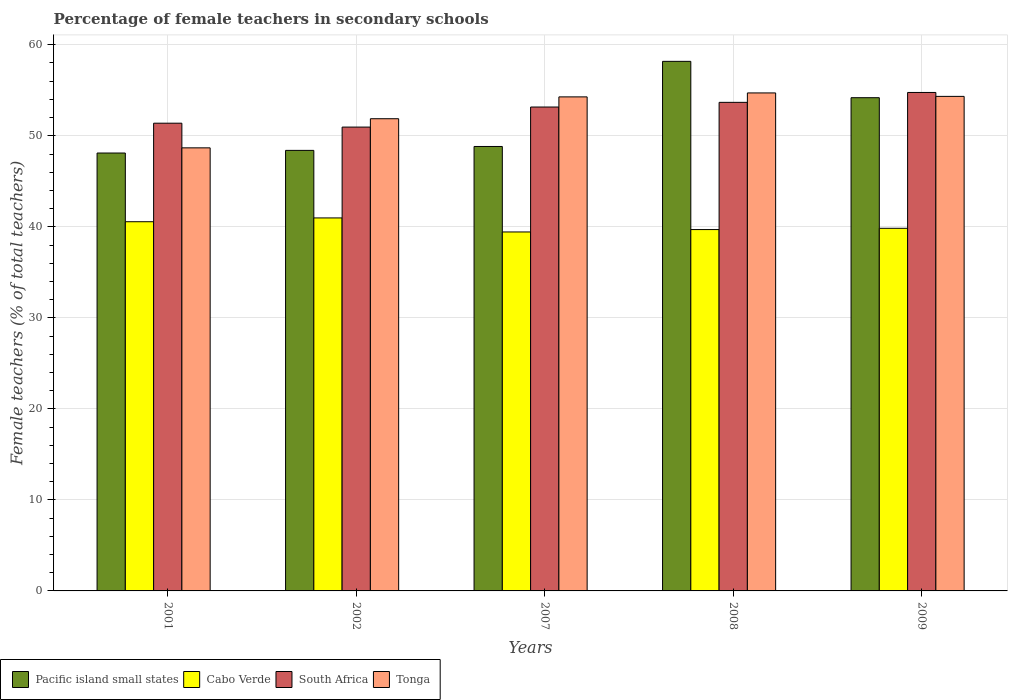How many different coloured bars are there?
Your answer should be very brief. 4. Are the number of bars on each tick of the X-axis equal?
Provide a short and direct response. Yes. How many bars are there on the 4th tick from the left?
Keep it short and to the point. 4. How many bars are there on the 1st tick from the right?
Your response must be concise. 4. In how many cases, is the number of bars for a given year not equal to the number of legend labels?
Make the answer very short. 0. What is the percentage of female teachers in South Africa in 2001?
Your answer should be very brief. 51.39. Across all years, what is the maximum percentage of female teachers in Tonga?
Make the answer very short. 54.71. Across all years, what is the minimum percentage of female teachers in Tonga?
Provide a short and direct response. 48.68. What is the total percentage of female teachers in South Africa in the graph?
Give a very brief answer. 263.95. What is the difference between the percentage of female teachers in Cabo Verde in 2001 and that in 2007?
Ensure brevity in your answer.  1.13. What is the difference between the percentage of female teachers in Pacific island small states in 2008 and the percentage of female teachers in Cabo Verde in 2001?
Provide a succinct answer. 17.62. What is the average percentage of female teachers in Tonga per year?
Make the answer very short. 52.78. In the year 2002, what is the difference between the percentage of female teachers in Tonga and percentage of female teachers in Cabo Verde?
Your answer should be compact. 10.9. What is the ratio of the percentage of female teachers in South Africa in 2001 to that in 2007?
Provide a short and direct response. 0.97. Is the difference between the percentage of female teachers in Tonga in 2001 and 2008 greater than the difference between the percentage of female teachers in Cabo Verde in 2001 and 2008?
Make the answer very short. No. What is the difference between the highest and the second highest percentage of female teachers in Cabo Verde?
Keep it short and to the point. 0.42. What is the difference between the highest and the lowest percentage of female teachers in South Africa?
Your answer should be compact. 3.8. In how many years, is the percentage of female teachers in Tonga greater than the average percentage of female teachers in Tonga taken over all years?
Your answer should be compact. 3. Is it the case that in every year, the sum of the percentage of female teachers in Pacific island small states and percentage of female teachers in Cabo Verde is greater than the sum of percentage of female teachers in South Africa and percentage of female teachers in Tonga?
Provide a succinct answer. Yes. What does the 2nd bar from the left in 2008 represents?
Provide a succinct answer. Cabo Verde. What does the 4th bar from the right in 2001 represents?
Your response must be concise. Pacific island small states. Are all the bars in the graph horizontal?
Keep it short and to the point. No. How many years are there in the graph?
Ensure brevity in your answer.  5. What is the difference between two consecutive major ticks on the Y-axis?
Your answer should be compact. 10. Are the values on the major ticks of Y-axis written in scientific E-notation?
Provide a succinct answer. No. Where does the legend appear in the graph?
Offer a terse response. Bottom left. How many legend labels are there?
Your answer should be compact. 4. What is the title of the graph?
Make the answer very short. Percentage of female teachers in secondary schools. What is the label or title of the X-axis?
Offer a very short reply. Years. What is the label or title of the Y-axis?
Give a very brief answer. Female teachers (% of total teachers). What is the Female teachers (% of total teachers) in Pacific island small states in 2001?
Your answer should be very brief. 48.11. What is the Female teachers (% of total teachers) in Cabo Verde in 2001?
Provide a short and direct response. 40.56. What is the Female teachers (% of total teachers) in South Africa in 2001?
Your answer should be compact. 51.39. What is the Female teachers (% of total teachers) in Tonga in 2001?
Provide a succinct answer. 48.68. What is the Female teachers (% of total teachers) of Pacific island small states in 2002?
Keep it short and to the point. 48.4. What is the Female teachers (% of total teachers) in Cabo Verde in 2002?
Give a very brief answer. 40.98. What is the Female teachers (% of total teachers) of South Africa in 2002?
Offer a very short reply. 50.96. What is the Female teachers (% of total teachers) in Tonga in 2002?
Your answer should be compact. 51.88. What is the Female teachers (% of total teachers) of Pacific island small states in 2007?
Ensure brevity in your answer.  48.83. What is the Female teachers (% of total teachers) of Cabo Verde in 2007?
Keep it short and to the point. 39.44. What is the Female teachers (% of total teachers) of South Africa in 2007?
Make the answer very short. 53.16. What is the Female teachers (% of total teachers) in Tonga in 2007?
Your answer should be very brief. 54.28. What is the Female teachers (% of total teachers) of Pacific island small states in 2008?
Offer a very short reply. 58.18. What is the Female teachers (% of total teachers) of Cabo Verde in 2008?
Offer a very short reply. 39.7. What is the Female teachers (% of total teachers) in South Africa in 2008?
Provide a short and direct response. 53.68. What is the Female teachers (% of total teachers) of Tonga in 2008?
Ensure brevity in your answer.  54.71. What is the Female teachers (% of total teachers) in Pacific island small states in 2009?
Ensure brevity in your answer.  54.19. What is the Female teachers (% of total teachers) in Cabo Verde in 2009?
Provide a short and direct response. 39.84. What is the Female teachers (% of total teachers) of South Africa in 2009?
Provide a succinct answer. 54.76. What is the Female teachers (% of total teachers) in Tonga in 2009?
Your answer should be very brief. 54.33. Across all years, what is the maximum Female teachers (% of total teachers) of Pacific island small states?
Your response must be concise. 58.18. Across all years, what is the maximum Female teachers (% of total teachers) of Cabo Verde?
Provide a short and direct response. 40.98. Across all years, what is the maximum Female teachers (% of total teachers) in South Africa?
Offer a terse response. 54.76. Across all years, what is the maximum Female teachers (% of total teachers) in Tonga?
Give a very brief answer. 54.71. Across all years, what is the minimum Female teachers (% of total teachers) in Pacific island small states?
Your response must be concise. 48.11. Across all years, what is the minimum Female teachers (% of total teachers) of Cabo Verde?
Your answer should be very brief. 39.44. Across all years, what is the minimum Female teachers (% of total teachers) in South Africa?
Keep it short and to the point. 50.96. Across all years, what is the minimum Female teachers (% of total teachers) of Tonga?
Your answer should be very brief. 48.68. What is the total Female teachers (% of total teachers) in Pacific island small states in the graph?
Your answer should be very brief. 257.71. What is the total Female teachers (% of total teachers) in Cabo Verde in the graph?
Your answer should be very brief. 200.51. What is the total Female teachers (% of total teachers) of South Africa in the graph?
Your answer should be compact. 263.95. What is the total Female teachers (% of total teachers) in Tonga in the graph?
Provide a short and direct response. 263.88. What is the difference between the Female teachers (% of total teachers) of Pacific island small states in 2001 and that in 2002?
Your response must be concise. -0.29. What is the difference between the Female teachers (% of total teachers) of Cabo Verde in 2001 and that in 2002?
Provide a short and direct response. -0.42. What is the difference between the Female teachers (% of total teachers) of South Africa in 2001 and that in 2002?
Your response must be concise. 0.43. What is the difference between the Female teachers (% of total teachers) of Tonga in 2001 and that in 2002?
Provide a short and direct response. -3.2. What is the difference between the Female teachers (% of total teachers) of Pacific island small states in 2001 and that in 2007?
Offer a very short reply. -0.72. What is the difference between the Female teachers (% of total teachers) in Cabo Verde in 2001 and that in 2007?
Provide a succinct answer. 1.13. What is the difference between the Female teachers (% of total teachers) in South Africa in 2001 and that in 2007?
Make the answer very short. -1.78. What is the difference between the Female teachers (% of total teachers) in Tonga in 2001 and that in 2007?
Make the answer very short. -5.6. What is the difference between the Female teachers (% of total teachers) in Pacific island small states in 2001 and that in 2008?
Make the answer very short. -10.07. What is the difference between the Female teachers (% of total teachers) in Cabo Verde in 2001 and that in 2008?
Give a very brief answer. 0.86. What is the difference between the Female teachers (% of total teachers) of South Africa in 2001 and that in 2008?
Keep it short and to the point. -2.29. What is the difference between the Female teachers (% of total teachers) of Tonga in 2001 and that in 2008?
Ensure brevity in your answer.  -6.03. What is the difference between the Female teachers (% of total teachers) in Pacific island small states in 2001 and that in 2009?
Make the answer very short. -6.08. What is the difference between the Female teachers (% of total teachers) in Cabo Verde in 2001 and that in 2009?
Provide a short and direct response. 0.72. What is the difference between the Female teachers (% of total teachers) of South Africa in 2001 and that in 2009?
Ensure brevity in your answer.  -3.38. What is the difference between the Female teachers (% of total teachers) in Tonga in 2001 and that in 2009?
Offer a terse response. -5.65. What is the difference between the Female teachers (% of total teachers) in Pacific island small states in 2002 and that in 2007?
Offer a terse response. -0.43. What is the difference between the Female teachers (% of total teachers) in Cabo Verde in 2002 and that in 2007?
Give a very brief answer. 1.54. What is the difference between the Female teachers (% of total teachers) in South Africa in 2002 and that in 2007?
Your answer should be compact. -2.21. What is the difference between the Female teachers (% of total teachers) in Tonga in 2002 and that in 2007?
Your answer should be very brief. -2.4. What is the difference between the Female teachers (% of total teachers) of Pacific island small states in 2002 and that in 2008?
Ensure brevity in your answer.  -9.78. What is the difference between the Female teachers (% of total teachers) in Cabo Verde in 2002 and that in 2008?
Your response must be concise. 1.28. What is the difference between the Female teachers (% of total teachers) of South Africa in 2002 and that in 2008?
Give a very brief answer. -2.72. What is the difference between the Female teachers (% of total teachers) of Tonga in 2002 and that in 2008?
Your answer should be very brief. -2.83. What is the difference between the Female teachers (% of total teachers) in Pacific island small states in 2002 and that in 2009?
Provide a short and direct response. -5.79. What is the difference between the Female teachers (% of total teachers) of Cabo Verde in 2002 and that in 2009?
Your answer should be very brief. 1.14. What is the difference between the Female teachers (% of total teachers) of South Africa in 2002 and that in 2009?
Make the answer very short. -3.8. What is the difference between the Female teachers (% of total teachers) in Tonga in 2002 and that in 2009?
Make the answer very short. -2.45. What is the difference between the Female teachers (% of total teachers) of Pacific island small states in 2007 and that in 2008?
Keep it short and to the point. -9.35. What is the difference between the Female teachers (% of total teachers) in Cabo Verde in 2007 and that in 2008?
Your response must be concise. -0.26. What is the difference between the Female teachers (% of total teachers) in South Africa in 2007 and that in 2008?
Offer a terse response. -0.51. What is the difference between the Female teachers (% of total teachers) in Tonga in 2007 and that in 2008?
Keep it short and to the point. -0.43. What is the difference between the Female teachers (% of total teachers) of Pacific island small states in 2007 and that in 2009?
Your response must be concise. -5.36. What is the difference between the Female teachers (% of total teachers) of Cabo Verde in 2007 and that in 2009?
Make the answer very short. -0.4. What is the difference between the Female teachers (% of total teachers) of South Africa in 2007 and that in 2009?
Your response must be concise. -1.6. What is the difference between the Female teachers (% of total teachers) in Tonga in 2007 and that in 2009?
Give a very brief answer. -0.06. What is the difference between the Female teachers (% of total teachers) of Pacific island small states in 2008 and that in 2009?
Offer a very short reply. 3.99. What is the difference between the Female teachers (% of total teachers) in Cabo Verde in 2008 and that in 2009?
Your response must be concise. -0.14. What is the difference between the Female teachers (% of total teachers) in South Africa in 2008 and that in 2009?
Provide a short and direct response. -1.09. What is the difference between the Female teachers (% of total teachers) in Tonga in 2008 and that in 2009?
Offer a terse response. 0.38. What is the difference between the Female teachers (% of total teachers) in Pacific island small states in 2001 and the Female teachers (% of total teachers) in Cabo Verde in 2002?
Your answer should be compact. 7.13. What is the difference between the Female teachers (% of total teachers) of Pacific island small states in 2001 and the Female teachers (% of total teachers) of South Africa in 2002?
Ensure brevity in your answer.  -2.85. What is the difference between the Female teachers (% of total teachers) of Pacific island small states in 2001 and the Female teachers (% of total teachers) of Tonga in 2002?
Provide a succinct answer. -3.77. What is the difference between the Female teachers (% of total teachers) of Cabo Verde in 2001 and the Female teachers (% of total teachers) of South Africa in 2002?
Keep it short and to the point. -10.4. What is the difference between the Female teachers (% of total teachers) in Cabo Verde in 2001 and the Female teachers (% of total teachers) in Tonga in 2002?
Give a very brief answer. -11.32. What is the difference between the Female teachers (% of total teachers) of South Africa in 2001 and the Female teachers (% of total teachers) of Tonga in 2002?
Give a very brief answer. -0.49. What is the difference between the Female teachers (% of total teachers) of Pacific island small states in 2001 and the Female teachers (% of total teachers) of Cabo Verde in 2007?
Provide a short and direct response. 8.67. What is the difference between the Female teachers (% of total teachers) of Pacific island small states in 2001 and the Female teachers (% of total teachers) of South Africa in 2007?
Your answer should be very brief. -5.05. What is the difference between the Female teachers (% of total teachers) of Pacific island small states in 2001 and the Female teachers (% of total teachers) of Tonga in 2007?
Give a very brief answer. -6.17. What is the difference between the Female teachers (% of total teachers) in Cabo Verde in 2001 and the Female teachers (% of total teachers) in South Africa in 2007?
Your response must be concise. -12.6. What is the difference between the Female teachers (% of total teachers) of Cabo Verde in 2001 and the Female teachers (% of total teachers) of Tonga in 2007?
Make the answer very short. -13.71. What is the difference between the Female teachers (% of total teachers) in South Africa in 2001 and the Female teachers (% of total teachers) in Tonga in 2007?
Your answer should be compact. -2.89. What is the difference between the Female teachers (% of total teachers) in Pacific island small states in 2001 and the Female teachers (% of total teachers) in Cabo Verde in 2008?
Your answer should be very brief. 8.41. What is the difference between the Female teachers (% of total teachers) in Pacific island small states in 2001 and the Female teachers (% of total teachers) in South Africa in 2008?
Your answer should be very brief. -5.57. What is the difference between the Female teachers (% of total teachers) in Pacific island small states in 2001 and the Female teachers (% of total teachers) in Tonga in 2008?
Ensure brevity in your answer.  -6.6. What is the difference between the Female teachers (% of total teachers) of Cabo Verde in 2001 and the Female teachers (% of total teachers) of South Africa in 2008?
Your response must be concise. -13.12. What is the difference between the Female teachers (% of total teachers) of Cabo Verde in 2001 and the Female teachers (% of total teachers) of Tonga in 2008?
Provide a succinct answer. -14.15. What is the difference between the Female teachers (% of total teachers) of South Africa in 2001 and the Female teachers (% of total teachers) of Tonga in 2008?
Keep it short and to the point. -3.32. What is the difference between the Female teachers (% of total teachers) in Pacific island small states in 2001 and the Female teachers (% of total teachers) in Cabo Verde in 2009?
Give a very brief answer. 8.27. What is the difference between the Female teachers (% of total teachers) in Pacific island small states in 2001 and the Female teachers (% of total teachers) in South Africa in 2009?
Offer a very short reply. -6.65. What is the difference between the Female teachers (% of total teachers) in Pacific island small states in 2001 and the Female teachers (% of total teachers) in Tonga in 2009?
Your answer should be compact. -6.22. What is the difference between the Female teachers (% of total teachers) in Cabo Verde in 2001 and the Female teachers (% of total teachers) in South Africa in 2009?
Give a very brief answer. -14.2. What is the difference between the Female teachers (% of total teachers) in Cabo Verde in 2001 and the Female teachers (% of total teachers) in Tonga in 2009?
Ensure brevity in your answer.  -13.77. What is the difference between the Female teachers (% of total teachers) in South Africa in 2001 and the Female teachers (% of total teachers) in Tonga in 2009?
Provide a short and direct response. -2.95. What is the difference between the Female teachers (% of total teachers) of Pacific island small states in 2002 and the Female teachers (% of total teachers) of Cabo Verde in 2007?
Your response must be concise. 8.96. What is the difference between the Female teachers (% of total teachers) in Pacific island small states in 2002 and the Female teachers (% of total teachers) in South Africa in 2007?
Ensure brevity in your answer.  -4.76. What is the difference between the Female teachers (% of total teachers) of Pacific island small states in 2002 and the Female teachers (% of total teachers) of Tonga in 2007?
Keep it short and to the point. -5.88. What is the difference between the Female teachers (% of total teachers) of Cabo Verde in 2002 and the Female teachers (% of total teachers) of South Africa in 2007?
Your answer should be compact. -12.19. What is the difference between the Female teachers (% of total teachers) in Cabo Verde in 2002 and the Female teachers (% of total teachers) in Tonga in 2007?
Your answer should be compact. -13.3. What is the difference between the Female teachers (% of total teachers) of South Africa in 2002 and the Female teachers (% of total teachers) of Tonga in 2007?
Your response must be concise. -3.32. What is the difference between the Female teachers (% of total teachers) in Pacific island small states in 2002 and the Female teachers (% of total teachers) in South Africa in 2008?
Offer a very short reply. -5.28. What is the difference between the Female teachers (% of total teachers) in Pacific island small states in 2002 and the Female teachers (% of total teachers) in Tonga in 2008?
Your answer should be compact. -6.31. What is the difference between the Female teachers (% of total teachers) of Cabo Verde in 2002 and the Female teachers (% of total teachers) of South Africa in 2008?
Keep it short and to the point. -12.7. What is the difference between the Female teachers (% of total teachers) of Cabo Verde in 2002 and the Female teachers (% of total teachers) of Tonga in 2008?
Provide a succinct answer. -13.73. What is the difference between the Female teachers (% of total teachers) of South Africa in 2002 and the Female teachers (% of total teachers) of Tonga in 2008?
Give a very brief answer. -3.75. What is the difference between the Female teachers (% of total teachers) of Pacific island small states in 2002 and the Female teachers (% of total teachers) of Cabo Verde in 2009?
Your response must be concise. 8.56. What is the difference between the Female teachers (% of total teachers) of Pacific island small states in 2002 and the Female teachers (% of total teachers) of South Africa in 2009?
Offer a very short reply. -6.36. What is the difference between the Female teachers (% of total teachers) in Pacific island small states in 2002 and the Female teachers (% of total teachers) in Tonga in 2009?
Make the answer very short. -5.93. What is the difference between the Female teachers (% of total teachers) of Cabo Verde in 2002 and the Female teachers (% of total teachers) of South Africa in 2009?
Your response must be concise. -13.78. What is the difference between the Female teachers (% of total teachers) of Cabo Verde in 2002 and the Female teachers (% of total teachers) of Tonga in 2009?
Offer a very short reply. -13.35. What is the difference between the Female teachers (% of total teachers) in South Africa in 2002 and the Female teachers (% of total teachers) in Tonga in 2009?
Keep it short and to the point. -3.37. What is the difference between the Female teachers (% of total teachers) of Pacific island small states in 2007 and the Female teachers (% of total teachers) of Cabo Verde in 2008?
Offer a very short reply. 9.13. What is the difference between the Female teachers (% of total teachers) in Pacific island small states in 2007 and the Female teachers (% of total teachers) in South Africa in 2008?
Ensure brevity in your answer.  -4.85. What is the difference between the Female teachers (% of total teachers) of Pacific island small states in 2007 and the Female teachers (% of total teachers) of Tonga in 2008?
Make the answer very short. -5.88. What is the difference between the Female teachers (% of total teachers) of Cabo Verde in 2007 and the Female teachers (% of total teachers) of South Africa in 2008?
Offer a very short reply. -14.24. What is the difference between the Female teachers (% of total teachers) of Cabo Verde in 2007 and the Female teachers (% of total teachers) of Tonga in 2008?
Provide a succinct answer. -15.27. What is the difference between the Female teachers (% of total teachers) in South Africa in 2007 and the Female teachers (% of total teachers) in Tonga in 2008?
Provide a succinct answer. -1.55. What is the difference between the Female teachers (% of total teachers) of Pacific island small states in 2007 and the Female teachers (% of total teachers) of Cabo Verde in 2009?
Ensure brevity in your answer.  8.99. What is the difference between the Female teachers (% of total teachers) in Pacific island small states in 2007 and the Female teachers (% of total teachers) in South Africa in 2009?
Offer a terse response. -5.93. What is the difference between the Female teachers (% of total teachers) of Pacific island small states in 2007 and the Female teachers (% of total teachers) of Tonga in 2009?
Provide a short and direct response. -5.5. What is the difference between the Female teachers (% of total teachers) of Cabo Verde in 2007 and the Female teachers (% of total teachers) of South Africa in 2009?
Make the answer very short. -15.33. What is the difference between the Female teachers (% of total teachers) in Cabo Verde in 2007 and the Female teachers (% of total teachers) in Tonga in 2009?
Offer a very short reply. -14.9. What is the difference between the Female teachers (% of total teachers) of South Africa in 2007 and the Female teachers (% of total teachers) of Tonga in 2009?
Your answer should be very brief. -1.17. What is the difference between the Female teachers (% of total teachers) of Pacific island small states in 2008 and the Female teachers (% of total teachers) of Cabo Verde in 2009?
Provide a short and direct response. 18.34. What is the difference between the Female teachers (% of total teachers) in Pacific island small states in 2008 and the Female teachers (% of total teachers) in South Africa in 2009?
Your answer should be very brief. 3.42. What is the difference between the Female teachers (% of total teachers) of Pacific island small states in 2008 and the Female teachers (% of total teachers) of Tonga in 2009?
Give a very brief answer. 3.85. What is the difference between the Female teachers (% of total teachers) of Cabo Verde in 2008 and the Female teachers (% of total teachers) of South Africa in 2009?
Your answer should be compact. -15.06. What is the difference between the Female teachers (% of total teachers) of Cabo Verde in 2008 and the Female teachers (% of total teachers) of Tonga in 2009?
Your answer should be compact. -14.63. What is the difference between the Female teachers (% of total teachers) in South Africa in 2008 and the Female teachers (% of total teachers) in Tonga in 2009?
Make the answer very short. -0.66. What is the average Female teachers (% of total teachers) of Pacific island small states per year?
Ensure brevity in your answer.  51.54. What is the average Female teachers (% of total teachers) in Cabo Verde per year?
Your answer should be very brief. 40.1. What is the average Female teachers (% of total teachers) of South Africa per year?
Ensure brevity in your answer.  52.79. What is the average Female teachers (% of total teachers) of Tonga per year?
Offer a very short reply. 52.78. In the year 2001, what is the difference between the Female teachers (% of total teachers) of Pacific island small states and Female teachers (% of total teachers) of Cabo Verde?
Keep it short and to the point. 7.55. In the year 2001, what is the difference between the Female teachers (% of total teachers) of Pacific island small states and Female teachers (% of total teachers) of South Africa?
Your response must be concise. -3.28. In the year 2001, what is the difference between the Female teachers (% of total teachers) of Pacific island small states and Female teachers (% of total teachers) of Tonga?
Your response must be concise. -0.57. In the year 2001, what is the difference between the Female teachers (% of total teachers) of Cabo Verde and Female teachers (% of total teachers) of South Africa?
Give a very brief answer. -10.82. In the year 2001, what is the difference between the Female teachers (% of total teachers) of Cabo Verde and Female teachers (% of total teachers) of Tonga?
Provide a short and direct response. -8.12. In the year 2001, what is the difference between the Female teachers (% of total teachers) of South Africa and Female teachers (% of total teachers) of Tonga?
Ensure brevity in your answer.  2.71. In the year 2002, what is the difference between the Female teachers (% of total teachers) of Pacific island small states and Female teachers (% of total teachers) of Cabo Verde?
Keep it short and to the point. 7.42. In the year 2002, what is the difference between the Female teachers (% of total teachers) in Pacific island small states and Female teachers (% of total teachers) in South Africa?
Ensure brevity in your answer.  -2.56. In the year 2002, what is the difference between the Female teachers (% of total teachers) in Pacific island small states and Female teachers (% of total teachers) in Tonga?
Make the answer very short. -3.48. In the year 2002, what is the difference between the Female teachers (% of total teachers) of Cabo Verde and Female teachers (% of total teachers) of South Africa?
Offer a terse response. -9.98. In the year 2002, what is the difference between the Female teachers (% of total teachers) in Cabo Verde and Female teachers (% of total teachers) in Tonga?
Your answer should be compact. -10.9. In the year 2002, what is the difference between the Female teachers (% of total teachers) in South Africa and Female teachers (% of total teachers) in Tonga?
Your response must be concise. -0.92. In the year 2007, what is the difference between the Female teachers (% of total teachers) in Pacific island small states and Female teachers (% of total teachers) in Cabo Verde?
Keep it short and to the point. 9.39. In the year 2007, what is the difference between the Female teachers (% of total teachers) in Pacific island small states and Female teachers (% of total teachers) in South Africa?
Your response must be concise. -4.33. In the year 2007, what is the difference between the Female teachers (% of total teachers) in Pacific island small states and Female teachers (% of total teachers) in Tonga?
Provide a short and direct response. -5.45. In the year 2007, what is the difference between the Female teachers (% of total teachers) in Cabo Verde and Female teachers (% of total teachers) in South Africa?
Your answer should be very brief. -13.73. In the year 2007, what is the difference between the Female teachers (% of total teachers) of Cabo Verde and Female teachers (% of total teachers) of Tonga?
Keep it short and to the point. -14.84. In the year 2007, what is the difference between the Female teachers (% of total teachers) of South Africa and Female teachers (% of total teachers) of Tonga?
Provide a short and direct response. -1.11. In the year 2008, what is the difference between the Female teachers (% of total teachers) in Pacific island small states and Female teachers (% of total teachers) in Cabo Verde?
Ensure brevity in your answer.  18.48. In the year 2008, what is the difference between the Female teachers (% of total teachers) of Pacific island small states and Female teachers (% of total teachers) of South Africa?
Your answer should be very brief. 4.5. In the year 2008, what is the difference between the Female teachers (% of total teachers) in Pacific island small states and Female teachers (% of total teachers) in Tonga?
Ensure brevity in your answer.  3.47. In the year 2008, what is the difference between the Female teachers (% of total teachers) of Cabo Verde and Female teachers (% of total teachers) of South Africa?
Keep it short and to the point. -13.98. In the year 2008, what is the difference between the Female teachers (% of total teachers) in Cabo Verde and Female teachers (% of total teachers) in Tonga?
Give a very brief answer. -15.01. In the year 2008, what is the difference between the Female teachers (% of total teachers) of South Africa and Female teachers (% of total teachers) of Tonga?
Give a very brief answer. -1.03. In the year 2009, what is the difference between the Female teachers (% of total teachers) in Pacific island small states and Female teachers (% of total teachers) in Cabo Verde?
Keep it short and to the point. 14.35. In the year 2009, what is the difference between the Female teachers (% of total teachers) in Pacific island small states and Female teachers (% of total teachers) in South Africa?
Your answer should be compact. -0.58. In the year 2009, what is the difference between the Female teachers (% of total teachers) in Pacific island small states and Female teachers (% of total teachers) in Tonga?
Your answer should be very brief. -0.14. In the year 2009, what is the difference between the Female teachers (% of total teachers) in Cabo Verde and Female teachers (% of total teachers) in South Africa?
Your answer should be very brief. -14.93. In the year 2009, what is the difference between the Female teachers (% of total teachers) of Cabo Verde and Female teachers (% of total teachers) of Tonga?
Your answer should be very brief. -14.49. In the year 2009, what is the difference between the Female teachers (% of total teachers) in South Africa and Female teachers (% of total teachers) in Tonga?
Ensure brevity in your answer.  0.43. What is the ratio of the Female teachers (% of total teachers) in Cabo Verde in 2001 to that in 2002?
Make the answer very short. 0.99. What is the ratio of the Female teachers (% of total teachers) in South Africa in 2001 to that in 2002?
Ensure brevity in your answer.  1.01. What is the ratio of the Female teachers (% of total teachers) in Tonga in 2001 to that in 2002?
Give a very brief answer. 0.94. What is the ratio of the Female teachers (% of total teachers) in Pacific island small states in 2001 to that in 2007?
Offer a very short reply. 0.99. What is the ratio of the Female teachers (% of total teachers) of Cabo Verde in 2001 to that in 2007?
Provide a short and direct response. 1.03. What is the ratio of the Female teachers (% of total teachers) of South Africa in 2001 to that in 2007?
Provide a succinct answer. 0.97. What is the ratio of the Female teachers (% of total teachers) in Tonga in 2001 to that in 2007?
Your response must be concise. 0.9. What is the ratio of the Female teachers (% of total teachers) of Pacific island small states in 2001 to that in 2008?
Provide a short and direct response. 0.83. What is the ratio of the Female teachers (% of total teachers) in Cabo Verde in 2001 to that in 2008?
Keep it short and to the point. 1.02. What is the ratio of the Female teachers (% of total teachers) in South Africa in 2001 to that in 2008?
Provide a succinct answer. 0.96. What is the ratio of the Female teachers (% of total teachers) of Tonga in 2001 to that in 2008?
Provide a succinct answer. 0.89. What is the ratio of the Female teachers (% of total teachers) of Pacific island small states in 2001 to that in 2009?
Offer a terse response. 0.89. What is the ratio of the Female teachers (% of total teachers) of Cabo Verde in 2001 to that in 2009?
Offer a very short reply. 1.02. What is the ratio of the Female teachers (% of total teachers) in South Africa in 2001 to that in 2009?
Make the answer very short. 0.94. What is the ratio of the Female teachers (% of total teachers) of Tonga in 2001 to that in 2009?
Keep it short and to the point. 0.9. What is the ratio of the Female teachers (% of total teachers) in Cabo Verde in 2002 to that in 2007?
Offer a terse response. 1.04. What is the ratio of the Female teachers (% of total teachers) of South Africa in 2002 to that in 2007?
Provide a succinct answer. 0.96. What is the ratio of the Female teachers (% of total teachers) of Tonga in 2002 to that in 2007?
Keep it short and to the point. 0.96. What is the ratio of the Female teachers (% of total teachers) in Pacific island small states in 2002 to that in 2008?
Offer a terse response. 0.83. What is the ratio of the Female teachers (% of total teachers) of Cabo Verde in 2002 to that in 2008?
Your answer should be very brief. 1.03. What is the ratio of the Female teachers (% of total teachers) of South Africa in 2002 to that in 2008?
Give a very brief answer. 0.95. What is the ratio of the Female teachers (% of total teachers) in Tonga in 2002 to that in 2008?
Offer a terse response. 0.95. What is the ratio of the Female teachers (% of total teachers) in Pacific island small states in 2002 to that in 2009?
Ensure brevity in your answer.  0.89. What is the ratio of the Female teachers (% of total teachers) of Cabo Verde in 2002 to that in 2009?
Make the answer very short. 1.03. What is the ratio of the Female teachers (% of total teachers) in South Africa in 2002 to that in 2009?
Keep it short and to the point. 0.93. What is the ratio of the Female teachers (% of total teachers) in Tonga in 2002 to that in 2009?
Provide a succinct answer. 0.95. What is the ratio of the Female teachers (% of total teachers) of Pacific island small states in 2007 to that in 2008?
Keep it short and to the point. 0.84. What is the ratio of the Female teachers (% of total teachers) of South Africa in 2007 to that in 2008?
Your answer should be very brief. 0.99. What is the ratio of the Female teachers (% of total teachers) in Tonga in 2007 to that in 2008?
Your response must be concise. 0.99. What is the ratio of the Female teachers (% of total teachers) of Pacific island small states in 2007 to that in 2009?
Provide a short and direct response. 0.9. What is the ratio of the Female teachers (% of total teachers) in Cabo Verde in 2007 to that in 2009?
Offer a very short reply. 0.99. What is the ratio of the Female teachers (% of total teachers) in South Africa in 2007 to that in 2009?
Your response must be concise. 0.97. What is the ratio of the Female teachers (% of total teachers) of Tonga in 2007 to that in 2009?
Provide a succinct answer. 1. What is the ratio of the Female teachers (% of total teachers) in Pacific island small states in 2008 to that in 2009?
Provide a succinct answer. 1.07. What is the ratio of the Female teachers (% of total teachers) of Cabo Verde in 2008 to that in 2009?
Provide a succinct answer. 1. What is the ratio of the Female teachers (% of total teachers) in South Africa in 2008 to that in 2009?
Provide a short and direct response. 0.98. What is the ratio of the Female teachers (% of total teachers) of Tonga in 2008 to that in 2009?
Keep it short and to the point. 1.01. What is the difference between the highest and the second highest Female teachers (% of total teachers) in Pacific island small states?
Offer a terse response. 3.99. What is the difference between the highest and the second highest Female teachers (% of total teachers) of Cabo Verde?
Give a very brief answer. 0.42. What is the difference between the highest and the second highest Female teachers (% of total teachers) in South Africa?
Your response must be concise. 1.09. What is the difference between the highest and the second highest Female teachers (% of total teachers) in Tonga?
Provide a succinct answer. 0.38. What is the difference between the highest and the lowest Female teachers (% of total teachers) in Pacific island small states?
Offer a terse response. 10.07. What is the difference between the highest and the lowest Female teachers (% of total teachers) in Cabo Verde?
Ensure brevity in your answer.  1.54. What is the difference between the highest and the lowest Female teachers (% of total teachers) in South Africa?
Provide a short and direct response. 3.8. What is the difference between the highest and the lowest Female teachers (% of total teachers) in Tonga?
Provide a short and direct response. 6.03. 